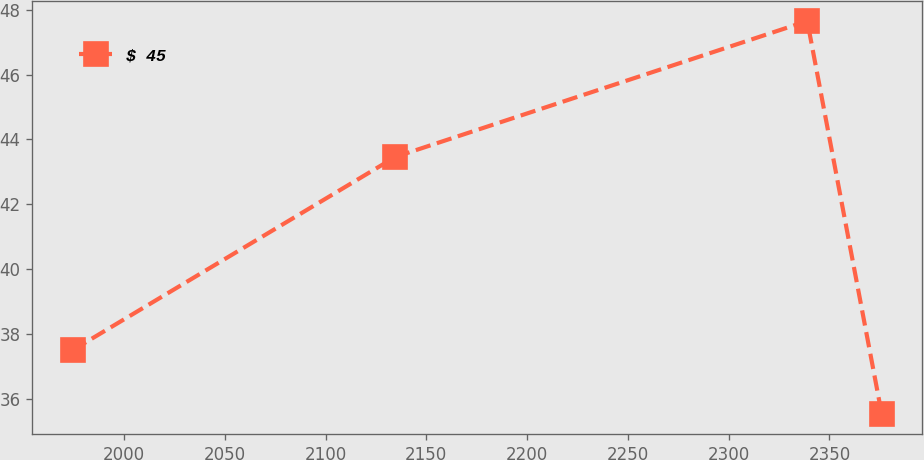Convert chart. <chart><loc_0><loc_0><loc_500><loc_500><line_chart><ecel><fcel>$ 45<nl><fcel>1974.62<fcel>37.5<nl><fcel>2134.7<fcel>43.46<nl><fcel>2338.98<fcel>47.65<nl><fcel>2375.95<fcel>35.52<nl></chart> 